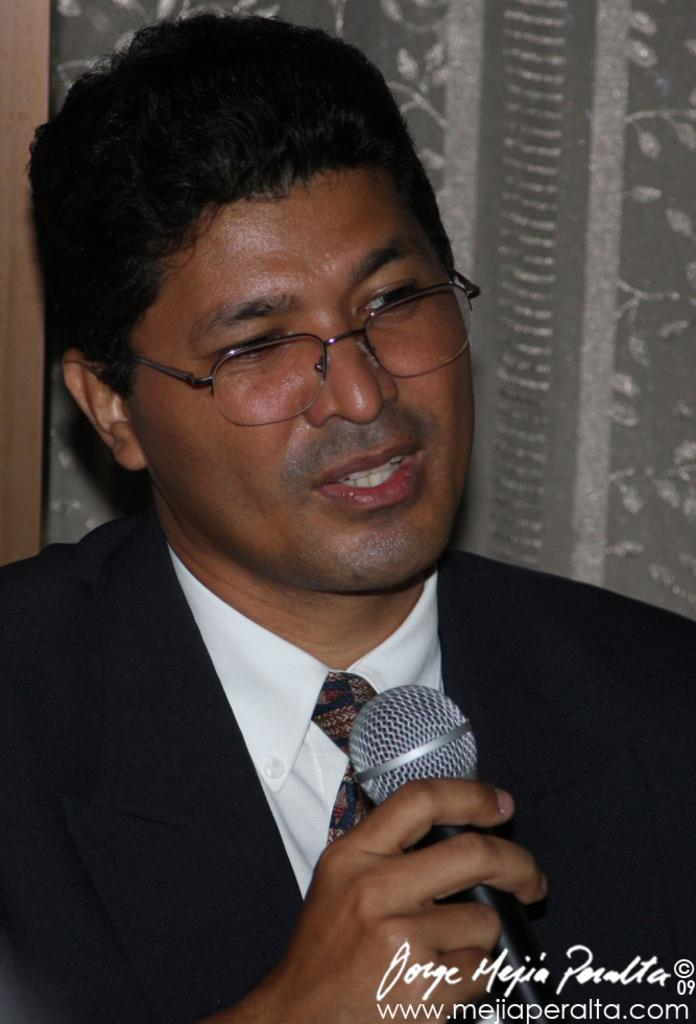What object is the person holding in the image? The person is holding a microphone. Can you describe the person's appearance in the image? The person is wearing glasses and a tie. What type of soda is the person drinking in the image? There is no soda present in the image; the person is holding a microphone. What emotion does the person appear to be experiencing in the image? The provided facts do not mention any emotions or expressions, so we cannot determine the person's emotional state from the image. 